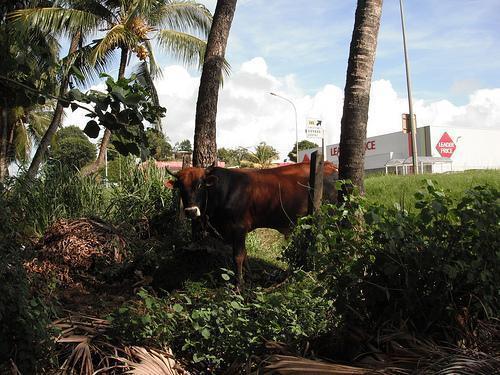How many horns does the bull have?
Give a very brief answer. 2. How many trees are pictured?
Give a very brief answer. 5. 